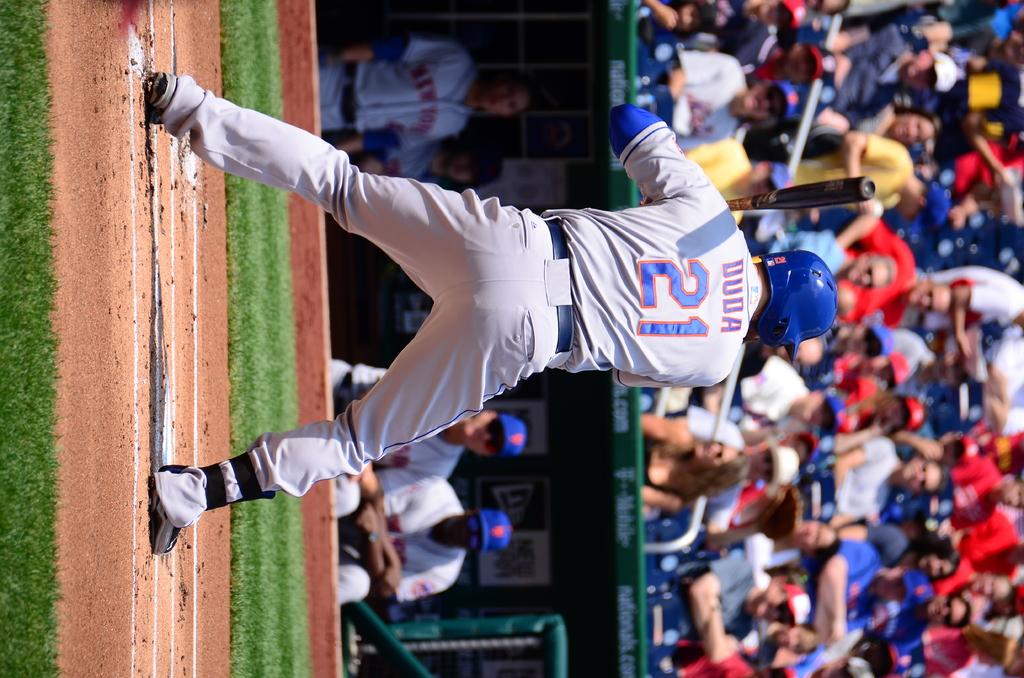<image>
Give a short and clear explanation of the subsequent image. Duda wearing number 21 jersey is on deck to bat 